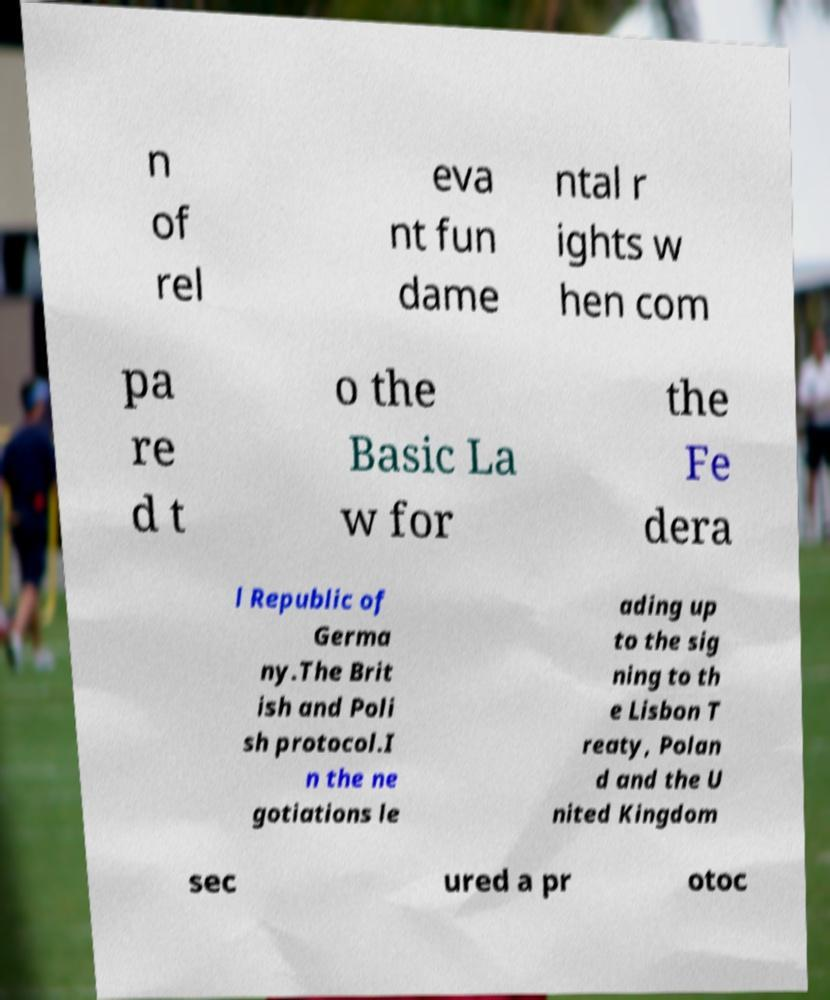What messages or text are displayed in this image? I need them in a readable, typed format. n of rel eva nt fun dame ntal r ights w hen com pa re d t o the Basic La w for the Fe dera l Republic of Germa ny.The Brit ish and Poli sh protocol.I n the ne gotiations le ading up to the sig ning to th e Lisbon T reaty, Polan d and the U nited Kingdom sec ured a pr otoc 